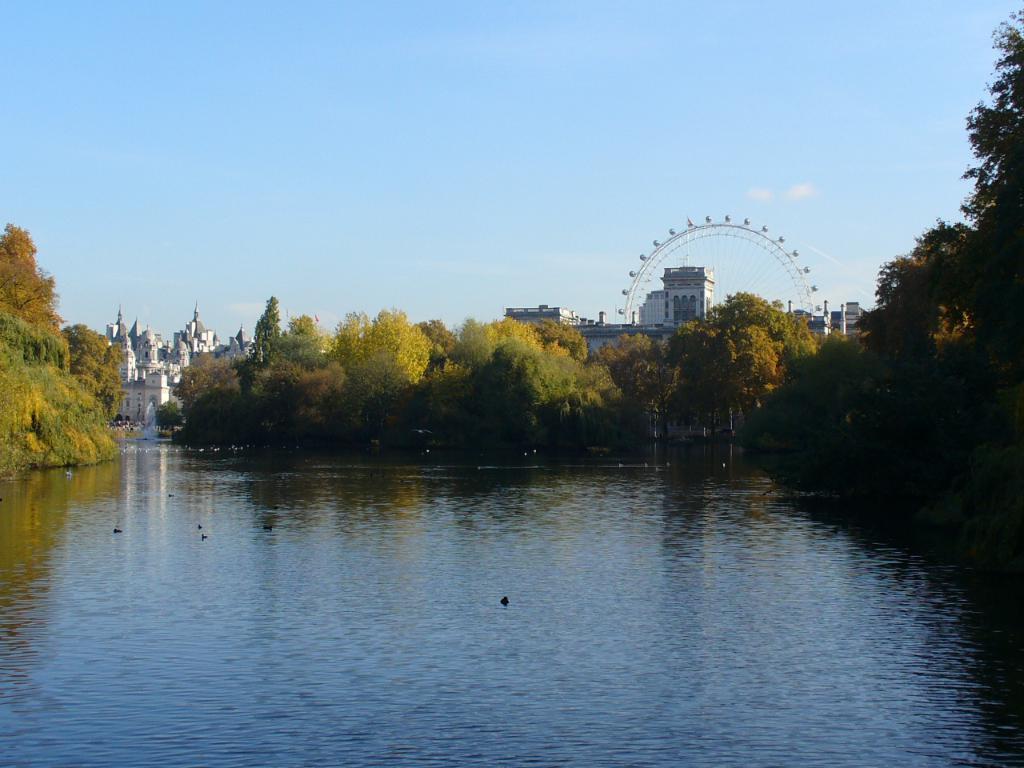Describe this image in one or two sentences. In this picture there buildings and trees and there is a joint wheel. At the top there is sky. At the bottom there are birds on the water. 